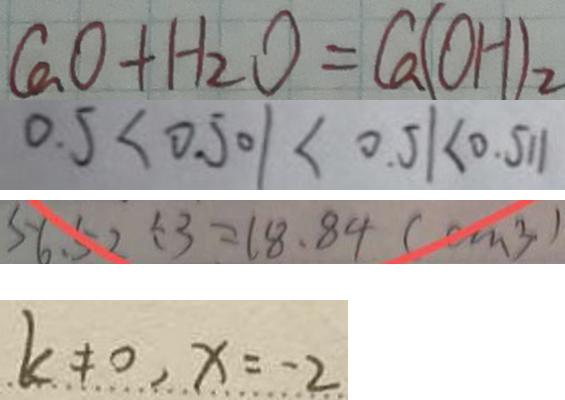Convert formula to latex. <formula><loc_0><loc_0><loc_500><loc_500>C a O + H _ { 2 } O = C a ( O H ) _ { 2 } 
 0 . 5 < 0 . 5 0 1 < 0 . 5 1 < 0 . 5 1 1 
 5 6 . 5 2 \div 3 = 1 8 . 8 4 ( c m ^ { 3 } ) 
 k \neq 0 , x = - 2</formula> 